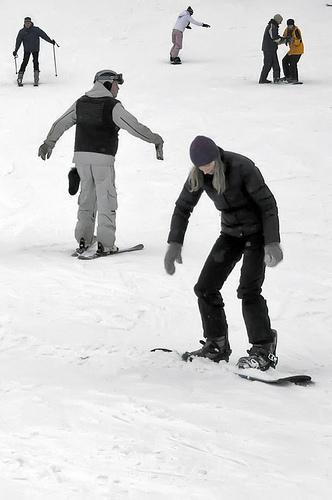What skill level do most snowboarders here have?

Choices:
A) beginners
B) professional
C) olympic
D) competitive beginners 